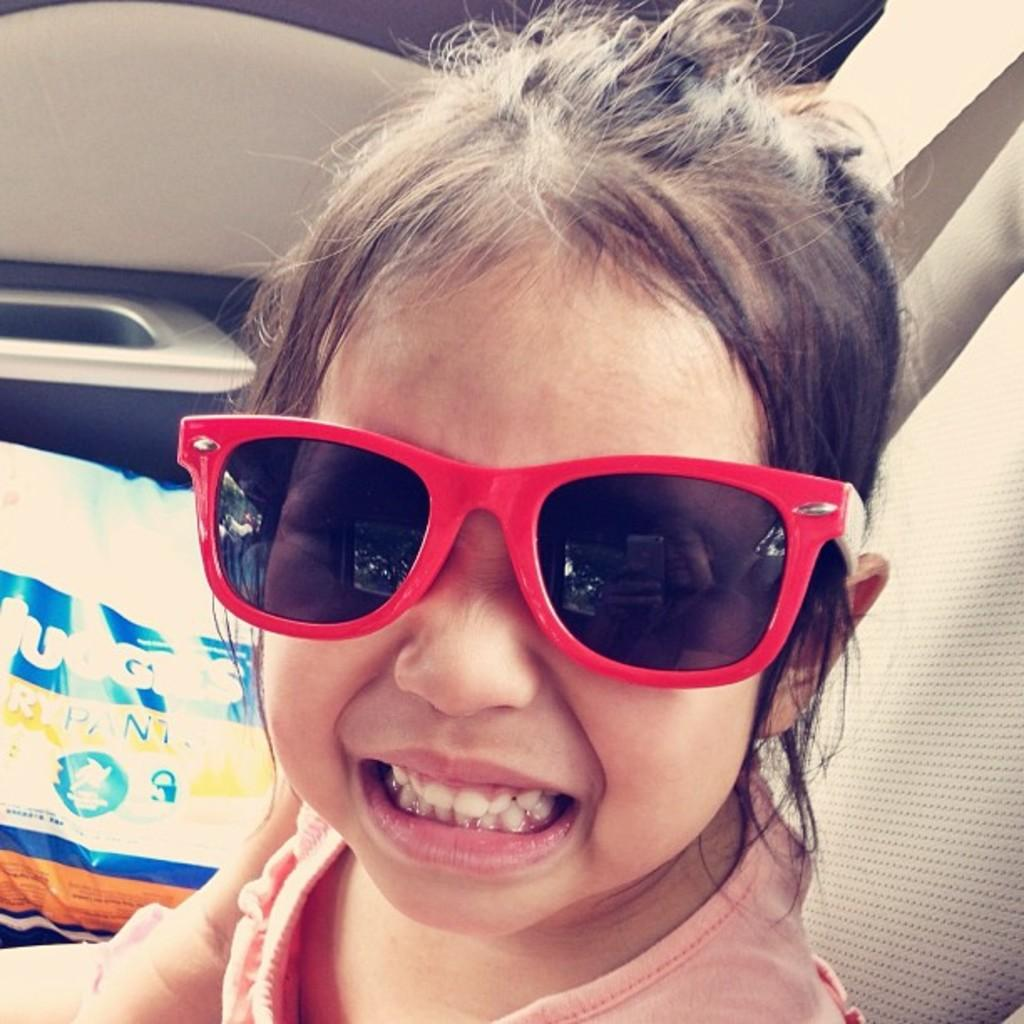Who is present in the image? There is a girl in the image. What is the girl wearing? The girl is wearing goggles. Where is the girl located in the image? The girl is sitting inside a vehicle. What can be seen beside the girl? There is an object beside the girl. What type of copper object is visible beside the girl in the image? There is no copper object present in the image. How does the worm affect the girl's impulse in the image? There is no worm or impulse mentioned in the image; it only features a girl wearing goggles and sitting inside a vehicle. 